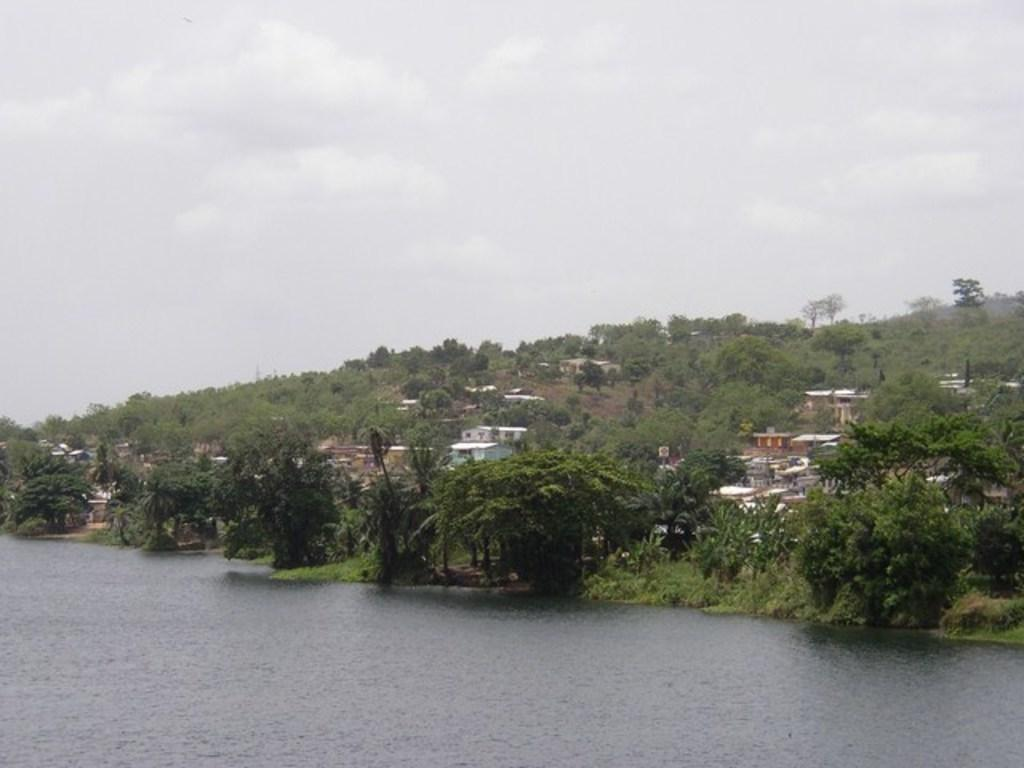What type of natural elements can be seen in the image? A: There are trees in the image. What type of man-made structures are present in the image? There are buildings in the image. What body of water is visible in the image? There is water visible in the image. What is the condition of the sky in the image? The sky is cloudy in the image. How many ducks are swimming in the water in the image? There are no ducks present in the image; it features trees, buildings, water, and a cloudy sky. What type of glove is hanging on the tree in the image? There is no glove present in the image; it only contains trees, buildings, water, and a cloudy sky. 